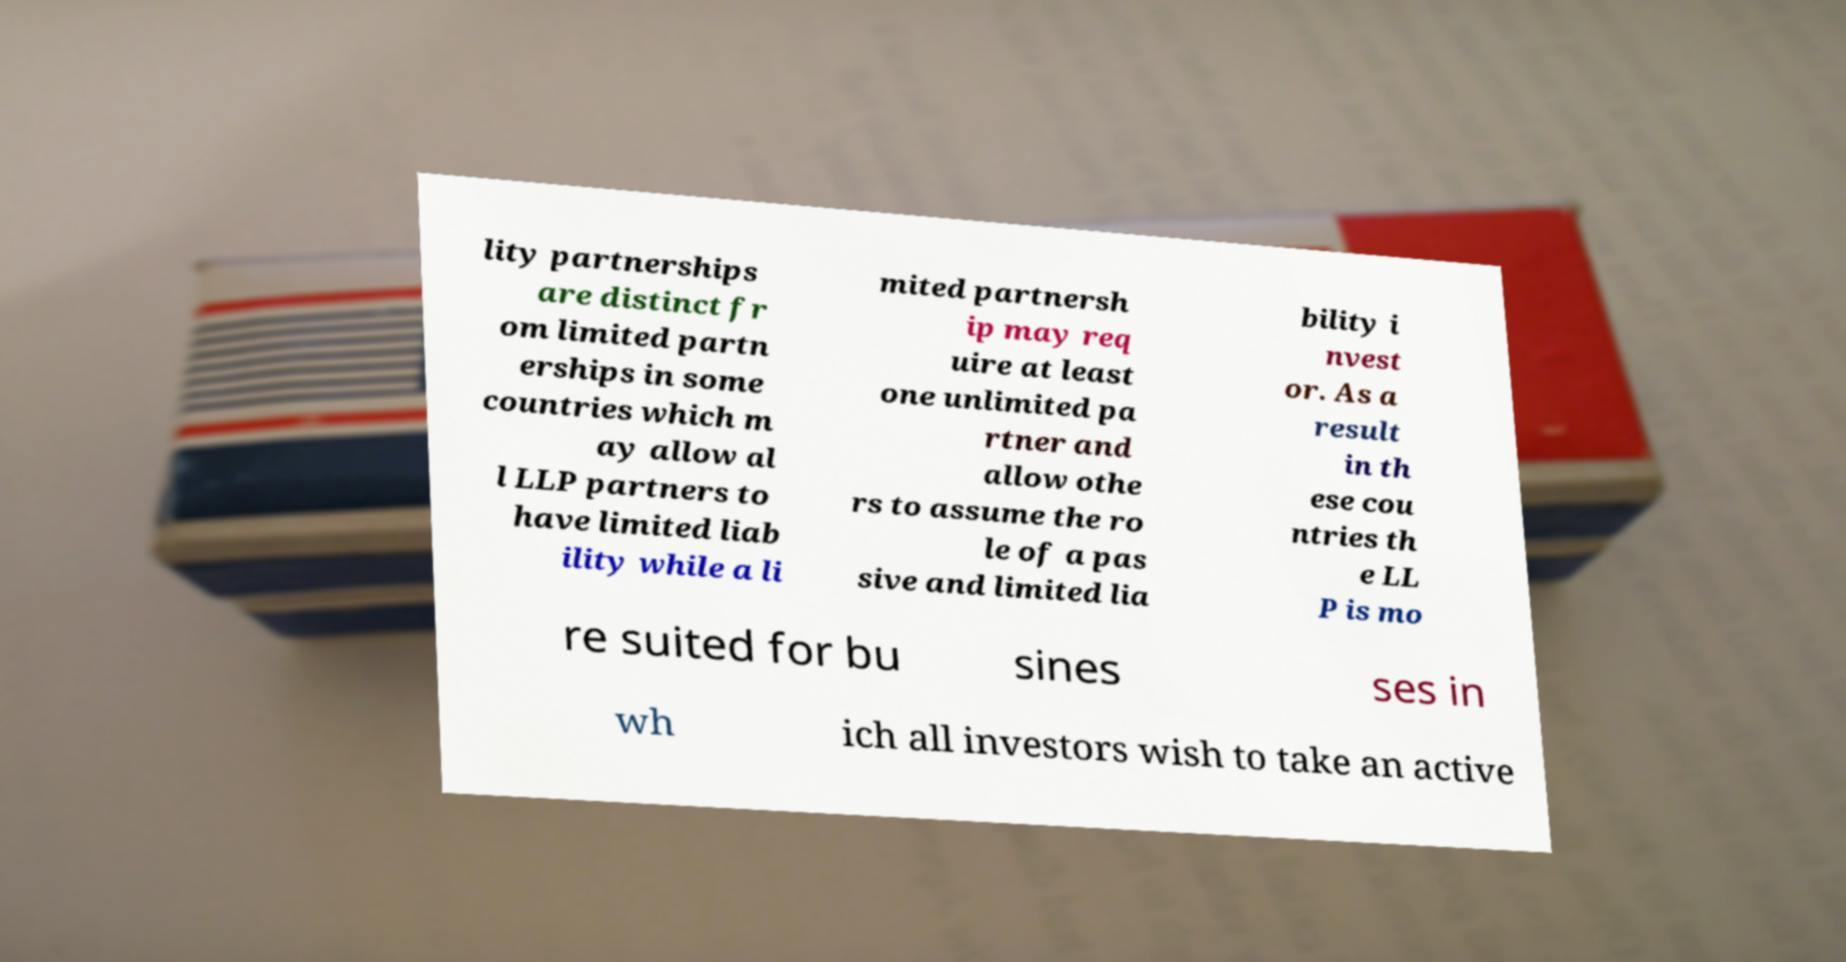Please read and relay the text visible in this image. What does it say? lity partnerships are distinct fr om limited partn erships in some countries which m ay allow al l LLP partners to have limited liab ility while a li mited partnersh ip may req uire at least one unlimited pa rtner and allow othe rs to assume the ro le of a pas sive and limited lia bility i nvest or. As a result in th ese cou ntries th e LL P is mo re suited for bu sines ses in wh ich all investors wish to take an active 